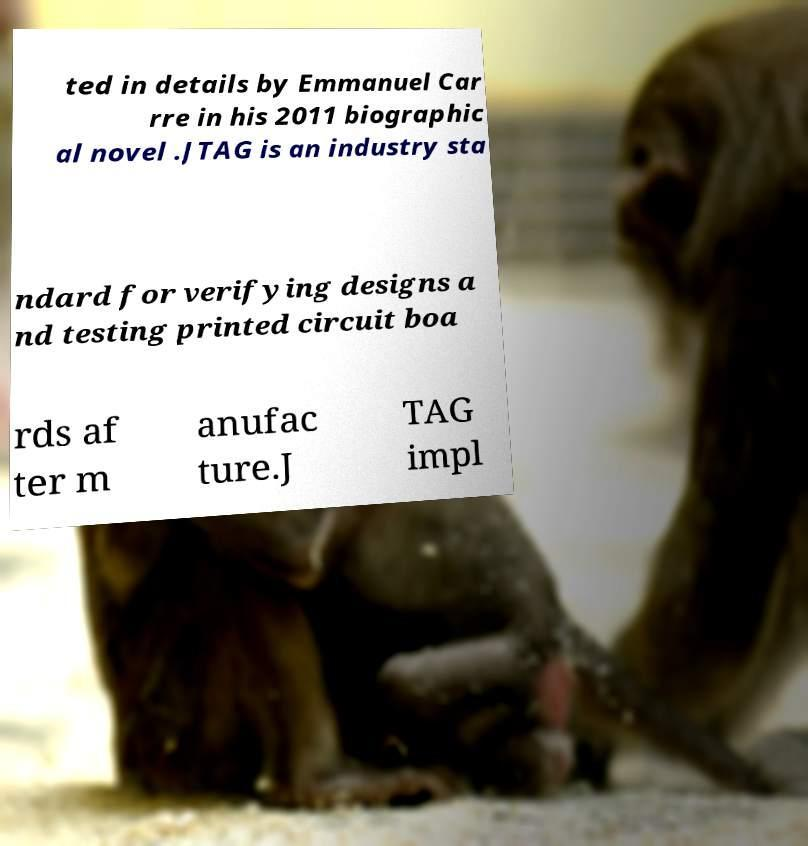Please read and relay the text visible in this image. What does it say? ted in details by Emmanuel Car rre in his 2011 biographic al novel .JTAG is an industry sta ndard for verifying designs a nd testing printed circuit boa rds af ter m anufac ture.J TAG impl 